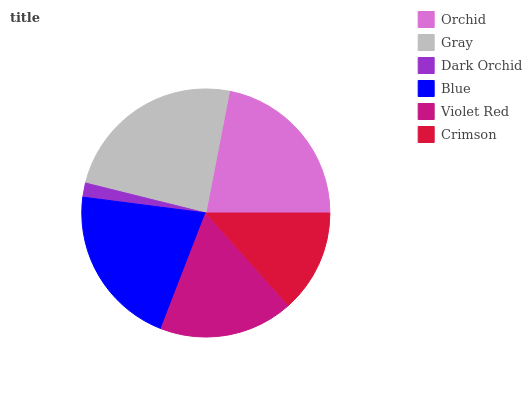Is Dark Orchid the minimum?
Answer yes or no. Yes. Is Gray the maximum?
Answer yes or no. Yes. Is Gray the minimum?
Answer yes or no. No. Is Dark Orchid the maximum?
Answer yes or no. No. Is Gray greater than Dark Orchid?
Answer yes or no. Yes. Is Dark Orchid less than Gray?
Answer yes or no. Yes. Is Dark Orchid greater than Gray?
Answer yes or no. No. Is Gray less than Dark Orchid?
Answer yes or no. No. Is Blue the high median?
Answer yes or no. Yes. Is Violet Red the low median?
Answer yes or no. Yes. Is Dark Orchid the high median?
Answer yes or no. No. Is Gray the low median?
Answer yes or no. No. 